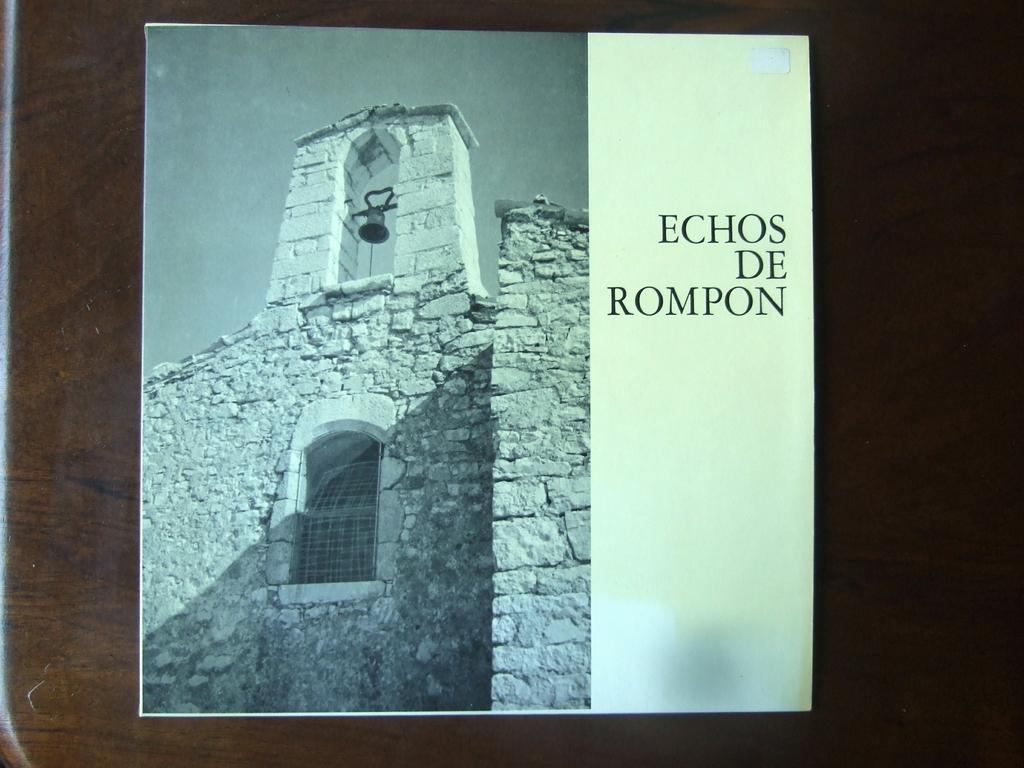<image>
Share a concise interpretation of the image provided. The book on the table is called Echos De Rompon. 